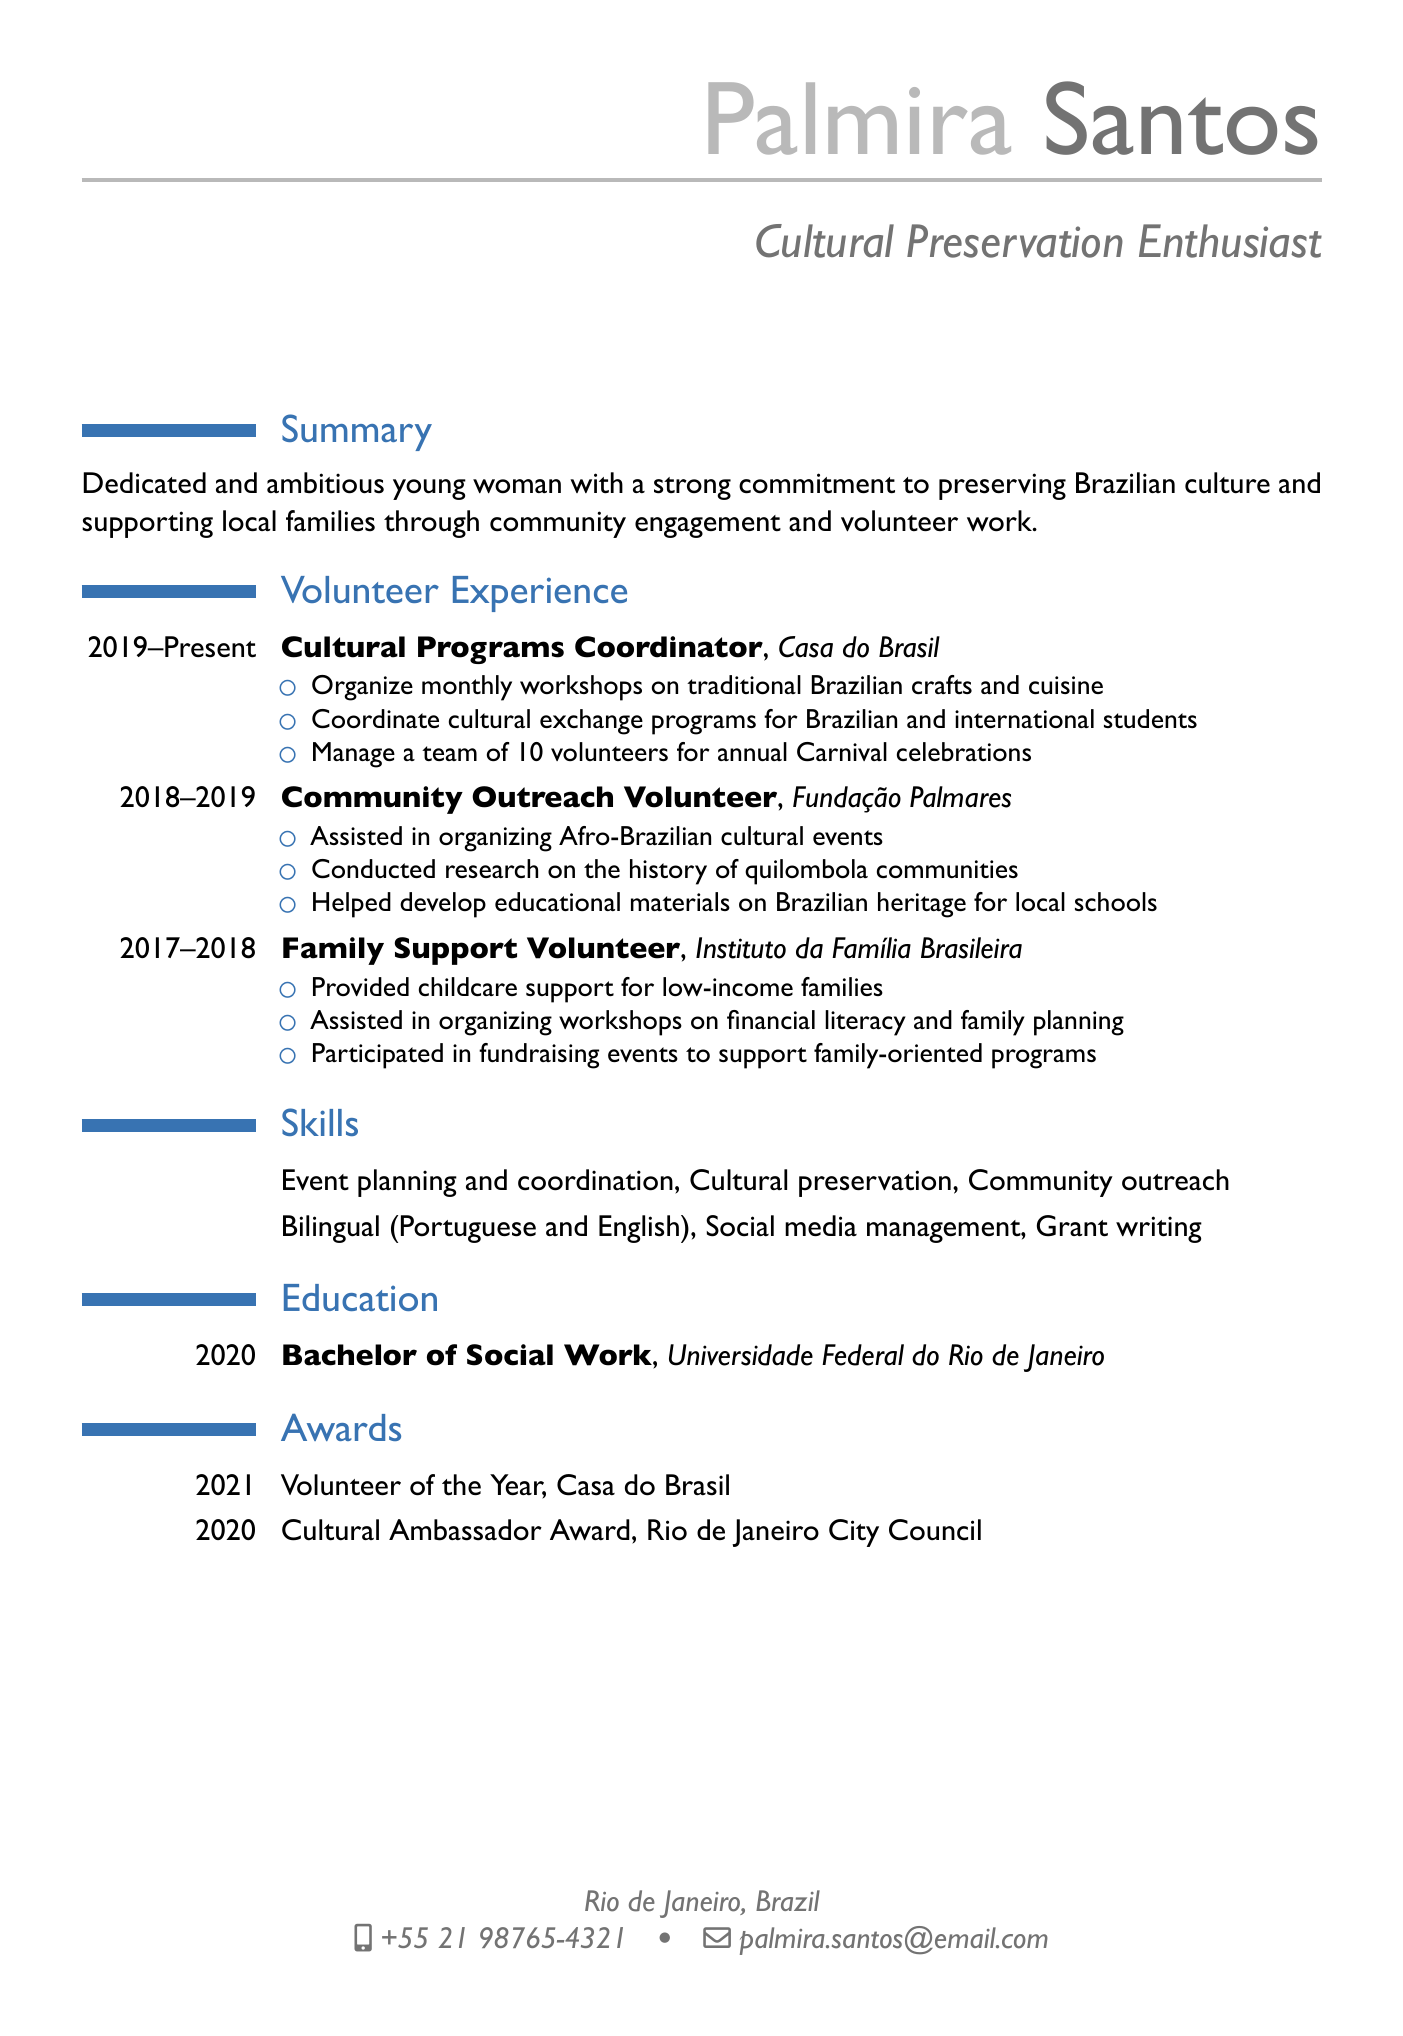What is Palmira's position at Casa do Brasil? Palmira is the Cultural Programs Coordinator at Casa do Brasil from 2019 to present.
Answer: Cultural Programs Coordinator When did Palmira graduate? Palmira graduated in 2020 with a Bachelor of Social Work from Universidade Federal do Rio de Janeiro.
Answer: 2020 What award did Palmira receive in 2021? Palmira was awarded Volunteer of the Year by Casa do Brasil in 2021.
Answer: Volunteer of the Year How many volunteers does Palmira manage for Carnival celebrations? The document states that Palmira manages a team of 10 volunteers for the Carnival celebrations at Casa do Brasil.
Answer: 10 What organization did Palmira work with before Casa do Brasil? The organization she volunteered with before Casa do Brasil is Fundação Palmares, where she was a Community Outreach Volunteer.
Answer: Fundação Palmares What type of workshops does Palmira organize at Casa do Brasil? She organizes monthly workshops on traditional Brazilian crafts and cuisine.
Answer: traditional Brazilian crafts and cuisine What is one of Palmira's skills listed in the document? One of the skills listed includes Event planning and coordination.
Answer: Event planning and coordination In which city does Palmira reside? The document indicates that Palmira resides in Rio de Janeiro, Brazil.
Answer: Rio de Janeiro What community focus does Palmira have in her volunteer work? Palmira's volunteer work focuses on preserving Brazilian culture and supporting local families.
Answer: Brazilian culture and supporting local families 